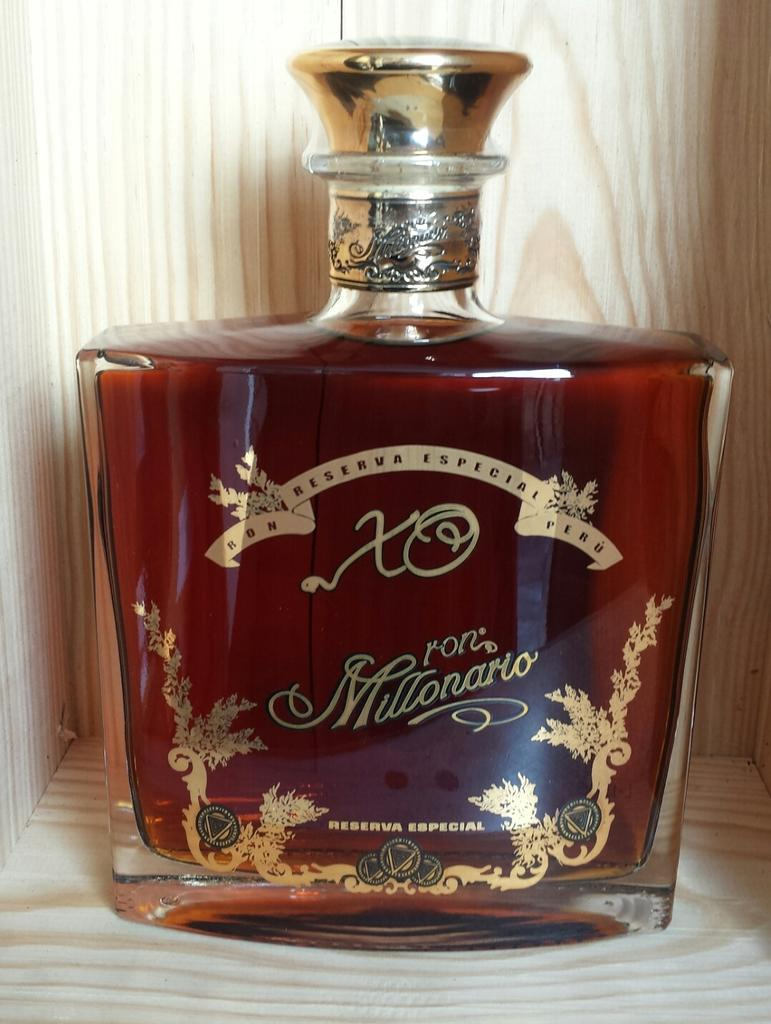<image>
Write a terse but informative summary of the picture. Large bottle with brown liquid inside and the words "Reserva Special" on the bottle. 